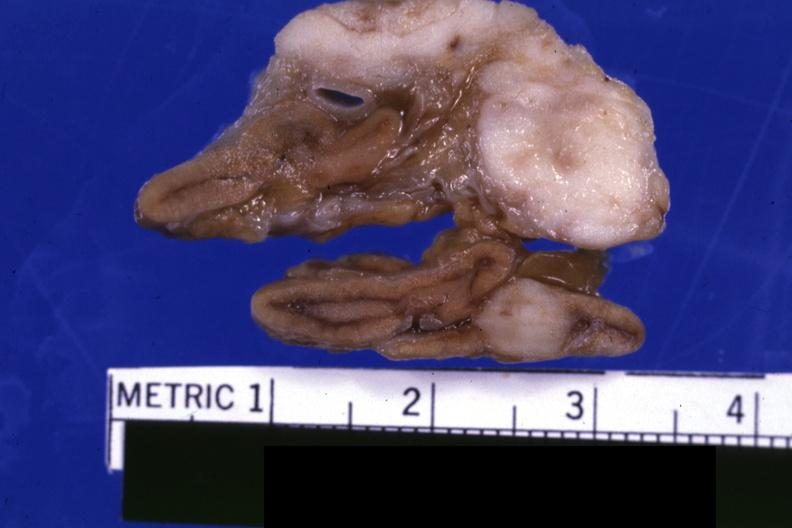s focal hemorrhagic infarction well shown present?
Answer the question using a single word or phrase. No 